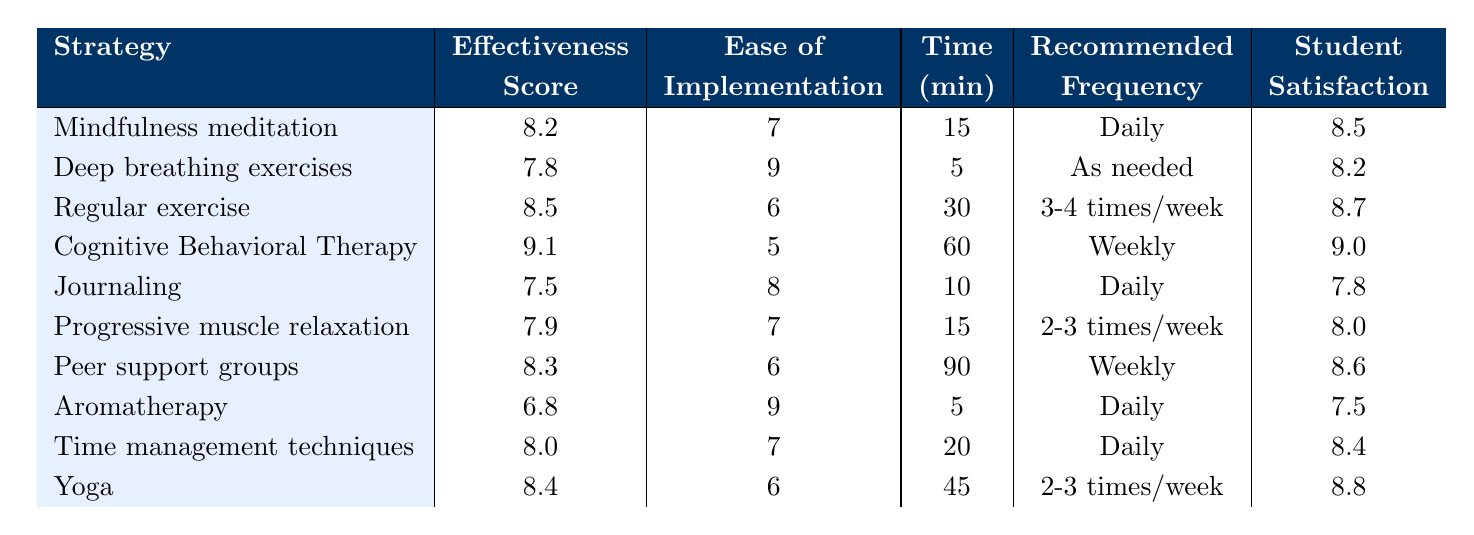What is the effectiveness score of Cognitive Behavioral Therapy (CBT)? The effectiveness score for CBT is directly listed in the table under the effectiveness score column. It is 9.1.
Answer: 9.1 Which coping strategy has the highest student satisfaction? The student satisfaction scores for each strategy are detailed in the table, and the highest score is found for Cognitive Behavioral Therapy (CBT) at 9.0.
Answer: Cognitive Behavioral Therapy (CBT) How long is the time commitment for Regular Exercise? The time commitment for Regular Exercise is listed under the time column, and it is 30 minutes.
Answer: 30 minutes What is the average effectiveness score of the coping strategies listed? To find the average, sum the effectiveness scores of all 10 strategies: (8.2 + 7.8 + 8.5 + 9.1 + 7.5 + 7.9 + 8.3 + 6.8 + 8.0 + 8.4) = 78.5, then divide by 10, so 78.5/10 = 7.85.
Answer: 7.85 Does Journaling have a higher ease of implementation score than Yoga? The ease of implementation for Journaling is 8, while for Yoga it is 6. Since 8 is greater than 6, Journaling does indeed have a higher score.
Answer: Yes Which coping strategy requires the most time commitment per session? To find this, compare the time commitment of each strategy. The longest time commitment is for Peer Support Groups at 90 minutes.
Answer: Peer Support Groups What is the effectiveness score difference between Deep Breathing Exercises and Aromatherapy? The effectiveness score for Deep Breathing Exercises is 7.8 and for Aromatherapy it is 6.8. The difference is calculated by subtracting 6.8 from 7.8, which is 1.0.
Answer: 1.0 How many coping strategies recommend a daily frequency? Looking at the recommended frequency column, Mindfulness Meditation, Journaling, Aromatherapy, and Time Management Techniques all recommend a daily frequency. There are 4 strategies.
Answer: 4 Is the student satisfaction score for Yoga higher than that for Deep Breathing Exercises? Yoga has a satisfaction score of 8.8 while Deep Breathing Exercises has a score of 8.2. Since 8.8 is greater than 8.2, the statement is true.
Answer: Yes What is the overall time commitment average for all coping strategies listed? First, sum the time commitments: (15 + 5 + 30 + 60 + 10 + 15 + 90 + 5 + 20 + 45) = 290 minutes. Then divide by 10 strategies to find the average: 290/10 = 29.
Answer: 29 minutes 